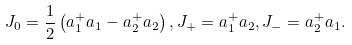<formula> <loc_0><loc_0><loc_500><loc_500>J _ { 0 } = \frac { 1 } { 2 } \left ( a _ { 1 } ^ { + } a _ { 1 } - a _ { 2 } ^ { + } a _ { 2 } \right ) , J _ { + } = a _ { 1 } ^ { + } a _ { 2 } , J _ { - } = a _ { 2 } ^ { + } a _ { 1 } .</formula> 